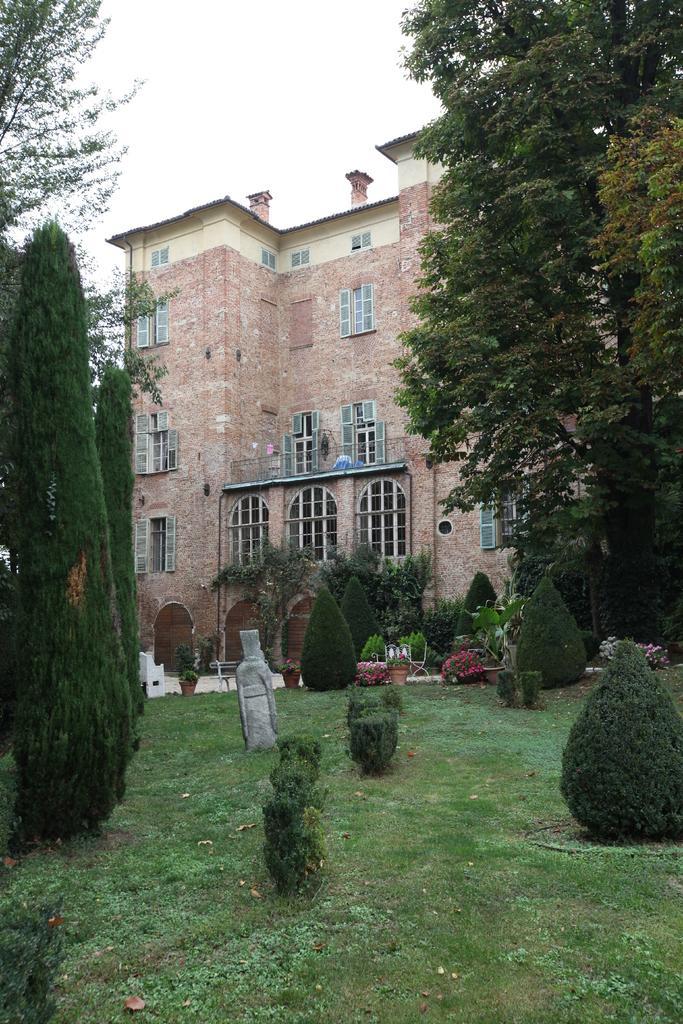How would you summarize this image in a sentence or two? In this picture there is a building. At the bottom we can see plants and grass. On the right and left side we can see trees. At the top we can see sky and clouds. 